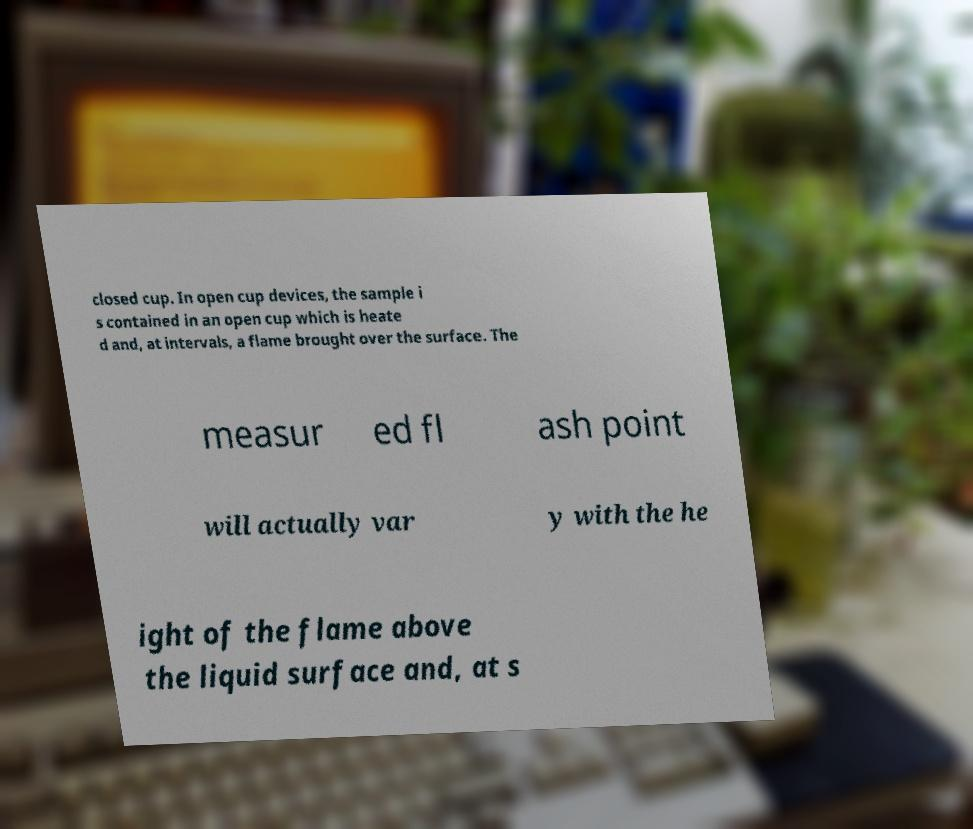Can you read and provide the text displayed in the image?This photo seems to have some interesting text. Can you extract and type it out for me? closed cup. In open cup devices, the sample i s contained in an open cup which is heate d and, at intervals, a flame brought over the surface. The measur ed fl ash point will actually var y with the he ight of the flame above the liquid surface and, at s 